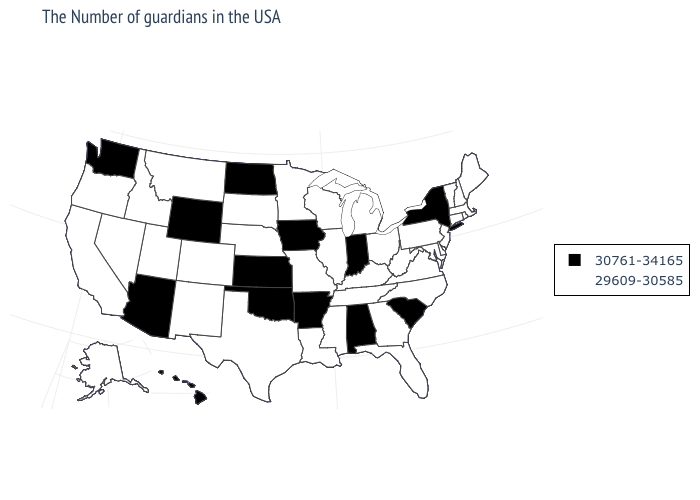Does Pennsylvania have the same value as Massachusetts?
Give a very brief answer. Yes. Name the states that have a value in the range 30761-34165?
Be succinct. New York, South Carolina, Indiana, Alabama, Arkansas, Iowa, Kansas, Oklahoma, North Dakota, Wyoming, Arizona, Washington, Hawaii. Name the states that have a value in the range 30761-34165?
Keep it brief. New York, South Carolina, Indiana, Alabama, Arkansas, Iowa, Kansas, Oklahoma, North Dakota, Wyoming, Arizona, Washington, Hawaii. What is the highest value in the South ?
Short answer required. 30761-34165. Is the legend a continuous bar?
Concise answer only. No. What is the value of Minnesota?
Give a very brief answer. 29609-30585. Among the states that border Oregon , does Washington have the highest value?
Quick response, please. Yes. What is the highest value in states that border Oklahoma?
Give a very brief answer. 30761-34165. Which states have the lowest value in the USA?
Keep it brief. Maine, Massachusetts, Rhode Island, New Hampshire, Vermont, Connecticut, New Jersey, Delaware, Maryland, Pennsylvania, Virginia, North Carolina, West Virginia, Ohio, Florida, Georgia, Michigan, Kentucky, Tennessee, Wisconsin, Illinois, Mississippi, Louisiana, Missouri, Minnesota, Nebraska, Texas, South Dakota, Colorado, New Mexico, Utah, Montana, Idaho, Nevada, California, Oregon, Alaska. Does Hawaii have the lowest value in the USA?
Quick response, please. No. What is the lowest value in the South?
Be succinct. 29609-30585. What is the value of Connecticut?
Keep it brief. 29609-30585. Does the first symbol in the legend represent the smallest category?
Be succinct. No. Name the states that have a value in the range 30761-34165?
Concise answer only. New York, South Carolina, Indiana, Alabama, Arkansas, Iowa, Kansas, Oklahoma, North Dakota, Wyoming, Arizona, Washington, Hawaii. Does Kansas have the highest value in the MidWest?
Concise answer only. Yes. 